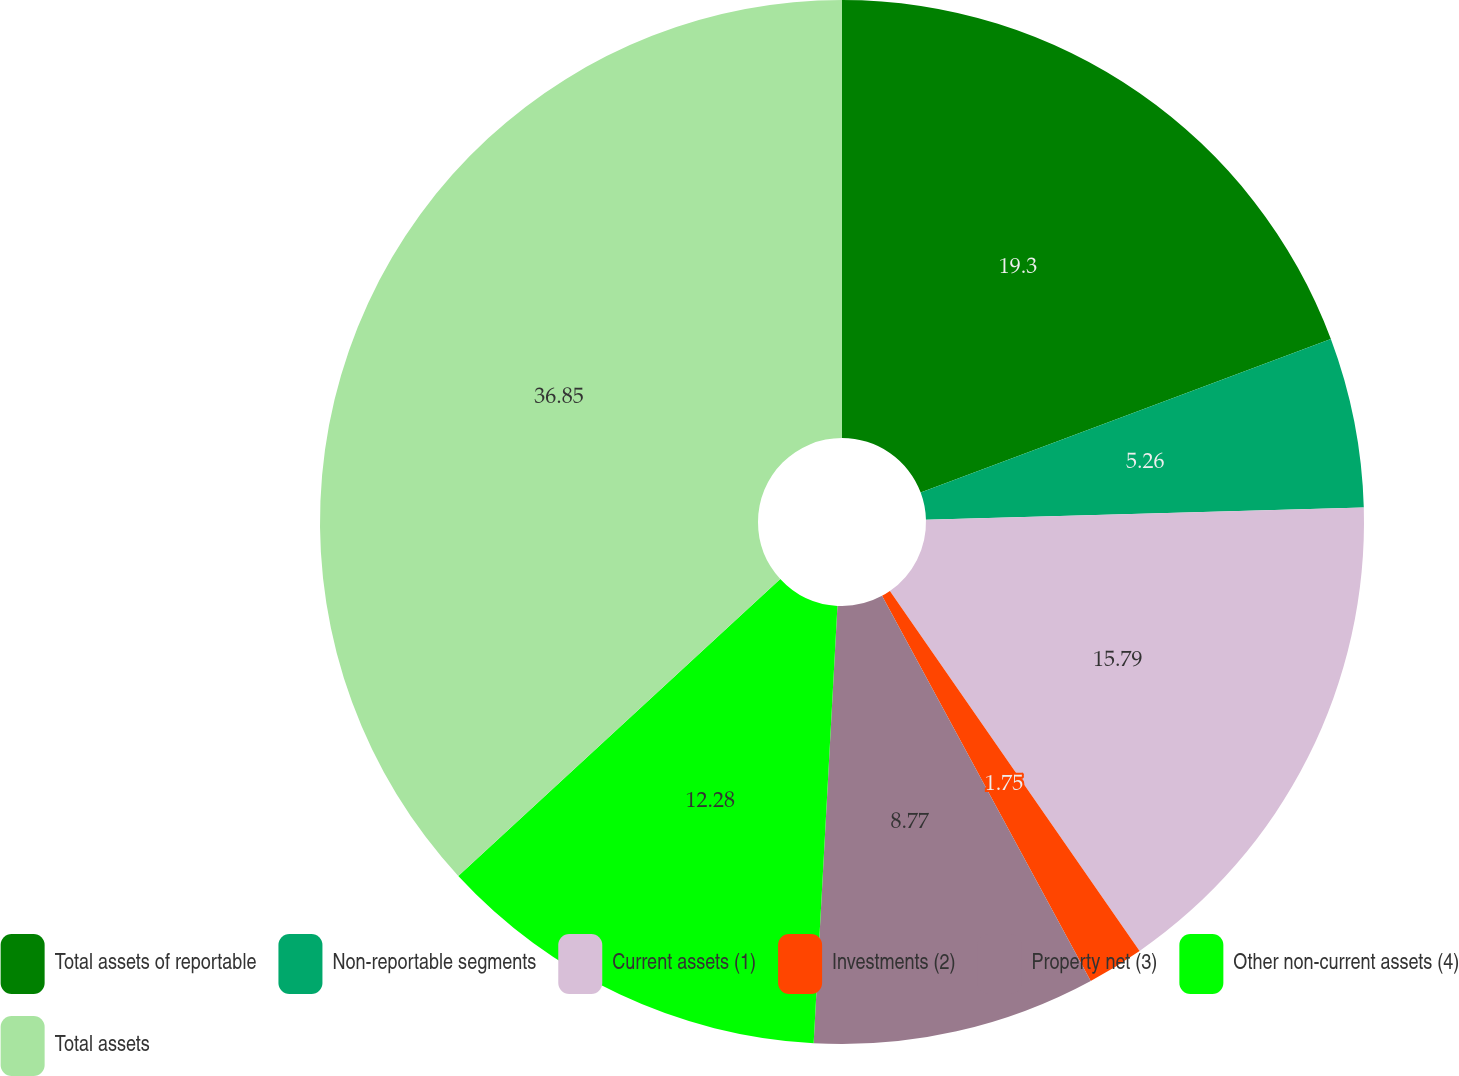<chart> <loc_0><loc_0><loc_500><loc_500><pie_chart><fcel>Total assets of reportable<fcel>Non-reportable segments<fcel>Current assets (1)<fcel>Investments (2)<fcel>Property net (3)<fcel>Other non-current assets (4)<fcel>Total assets<nl><fcel>19.3%<fcel>5.26%<fcel>15.79%<fcel>1.75%<fcel>8.77%<fcel>12.28%<fcel>36.86%<nl></chart> 